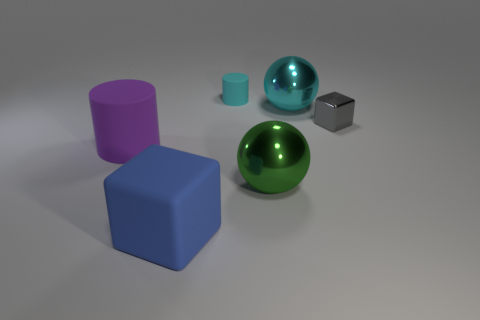Add 4 tiny purple matte things. How many objects exist? 10 Subtract all blocks. How many objects are left? 4 Subtract 0 blue spheres. How many objects are left? 6 Subtract all green metal things. Subtract all small gray shiny objects. How many objects are left? 4 Add 4 tiny matte cylinders. How many tiny matte cylinders are left? 5 Add 1 big brown rubber cubes. How many big brown rubber cubes exist? 1 